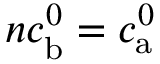<formula> <loc_0><loc_0><loc_500><loc_500>n c _ { b } ^ { 0 } = c _ { a } ^ { 0 }</formula> 